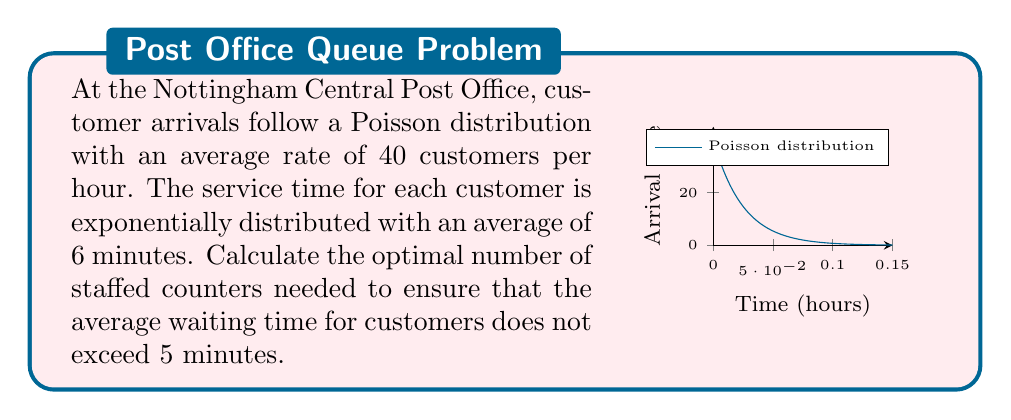Help me with this question. To solve this problem, we'll use the M/M/c queueing model, where M stands for Markovian (exponential) interarrival and service times, and c is the number of servers (counters).

Step 1: Define the parameters
- Arrival rate: $\lambda = 40$ customers/hour
- Service rate: $\mu = 60/6 = 10$ customers/hour per counter
- Maximum allowed average waiting time: $W_q = 5/60 = 1/12$ hour

Step 2: Calculate the utilization factor $\rho = \lambda/(c\mu)$
We need to find the minimum number of counters $c$ such that the average waiting time is less than 5 minutes.

Step 3: Use the Erlang C formula for average waiting time:
$$W_q = \frac{P_0 (\lambda/\mu)^c}{c!(c\mu - \lambda)} \cdot \frac{1}{c\mu - \lambda}$$

Where $P_0$ is the probability of an empty system:
$$P_0 = \left[\sum_{n=0}^{c-1} \frac{(\lambda/\mu)^n}{n!} + \frac{(\lambda/\mu)^c}{c!} \cdot \frac{c\mu}{c\mu - \lambda}\right]^{-1}$$

Step 4: Iterate through values of $c$ until $W_q \leq 1/12$

For $c = 5$:
$\rho = 40/(5 \cdot 10) = 0.8$
$P_0 \approx 0.0132$
$W_q \approx 0.1067$ hours $\approx 6.4$ minutes

For $c = 6$:
$\rho = 40/(6 \cdot 10) \approx 0.6667$
$P_0 \approx 0.0157$
$W_q \approx 0.0304$ hours $\approx 1.82$ minutes

Step 5: Check if the result satisfies the condition
Since $1.82 < 5$ minutes, 6 counters is the optimal number.
Answer: 6 counters 